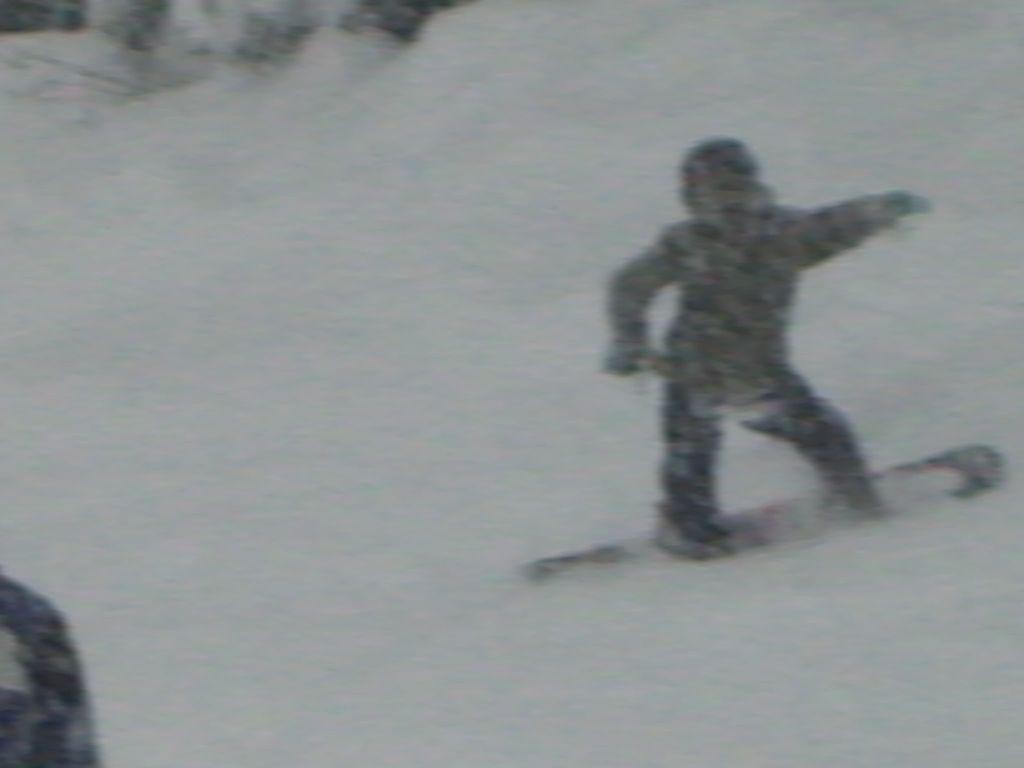Please provide a concise description of this image. It is a blur image. Here we can see a person is skating with a snowboard on the snow. 